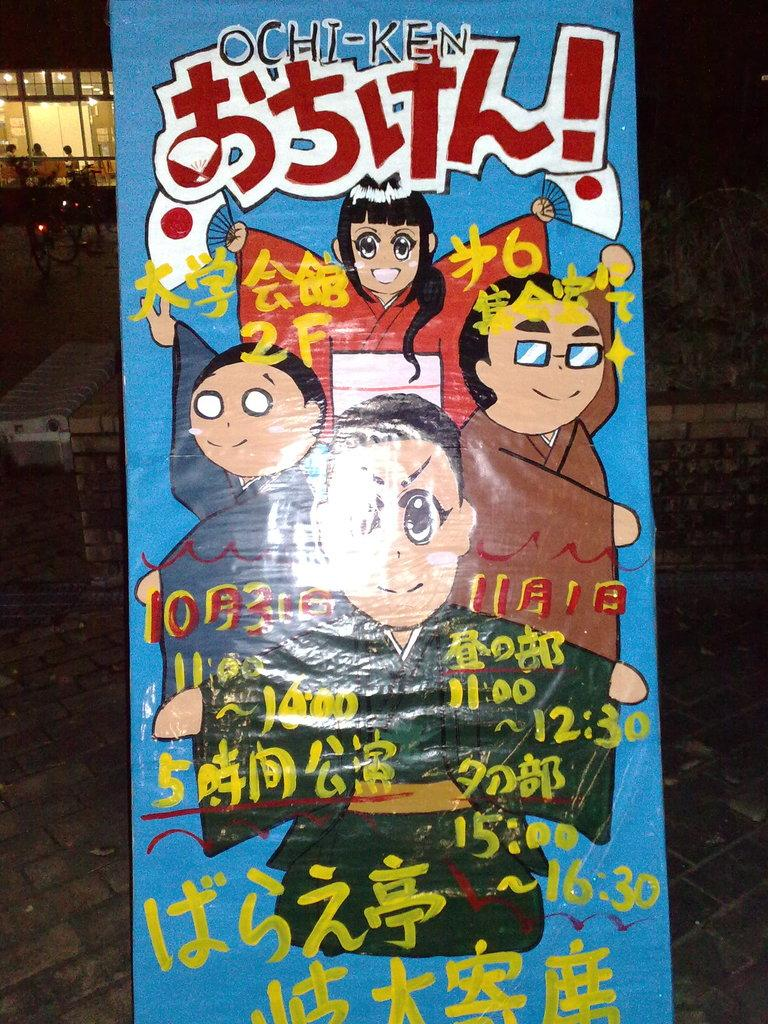What is the main object in the image? There is a poster in the image. What can be found on the poster? The poster contains images and text. What else can be seen in the background of the image? There are people and lights visible in the background of the image. What advice does the manager give to the people in the image? There is no manager present in the image, and therefore no advice can be given. 